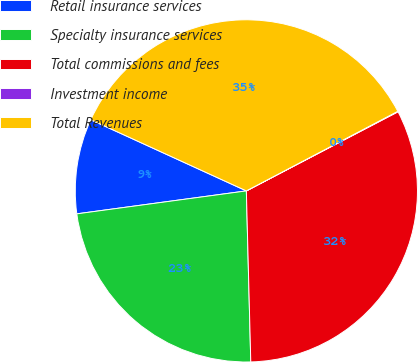<chart> <loc_0><loc_0><loc_500><loc_500><pie_chart><fcel>Retail insurance services<fcel>Specialty insurance services<fcel>Total commissions and fees<fcel>Investment income<fcel>Total Revenues<nl><fcel>8.97%<fcel>23.27%<fcel>32.24%<fcel>0.05%<fcel>35.47%<nl></chart> 